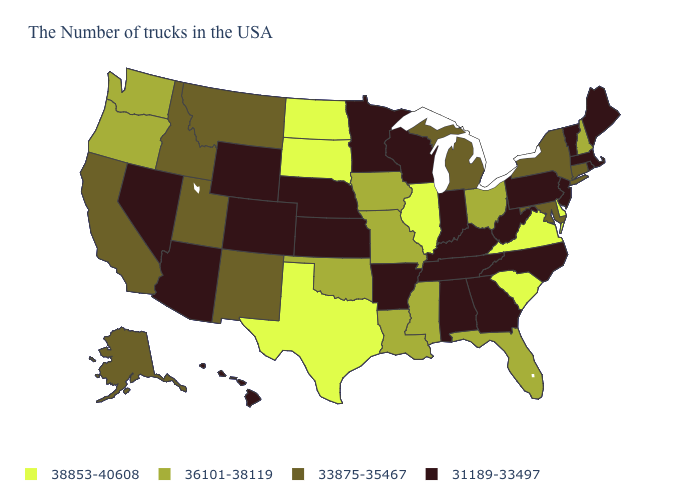Among the states that border New Mexico , which have the highest value?
Answer briefly. Texas. Name the states that have a value in the range 31189-33497?
Write a very short answer. Maine, Massachusetts, Rhode Island, Vermont, New Jersey, Pennsylvania, North Carolina, West Virginia, Georgia, Kentucky, Indiana, Alabama, Tennessee, Wisconsin, Arkansas, Minnesota, Kansas, Nebraska, Wyoming, Colorado, Arizona, Nevada, Hawaii. Does the first symbol in the legend represent the smallest category?
Write a very short answer. No. What is the value of Pennsylvania?
Answer briefly. 31189-33497. Does Michigan have a lower value than Oregon?
Short answer required. Yes. Does Nevada have the highest value in the West?
Quick response, please. No. Name the states that have a value in the range 38853-40608?
Be succinct. Delaware, Virginia, South Carolina, Illinois, Texas, South Dakota, North Dakota. What is the highest value in the USA?
Write a very short answer. 38853-40608. Is the legend a continuous bar?
Keep it brief. No. Does North Dakota have a higher value than New Jersey?
Give a very brief answer. Yes. Among the states that border Tennessee , does Virginia have the highest value?
Give a very brief answer. Yes. What is the value of Ohio?
Short answer required. 36101-38119. What is the highest value in the USA?
Answer briefly. 38853-40608. What is the lowest value in the MidWest?
Concise answer only. 31189-33497. 